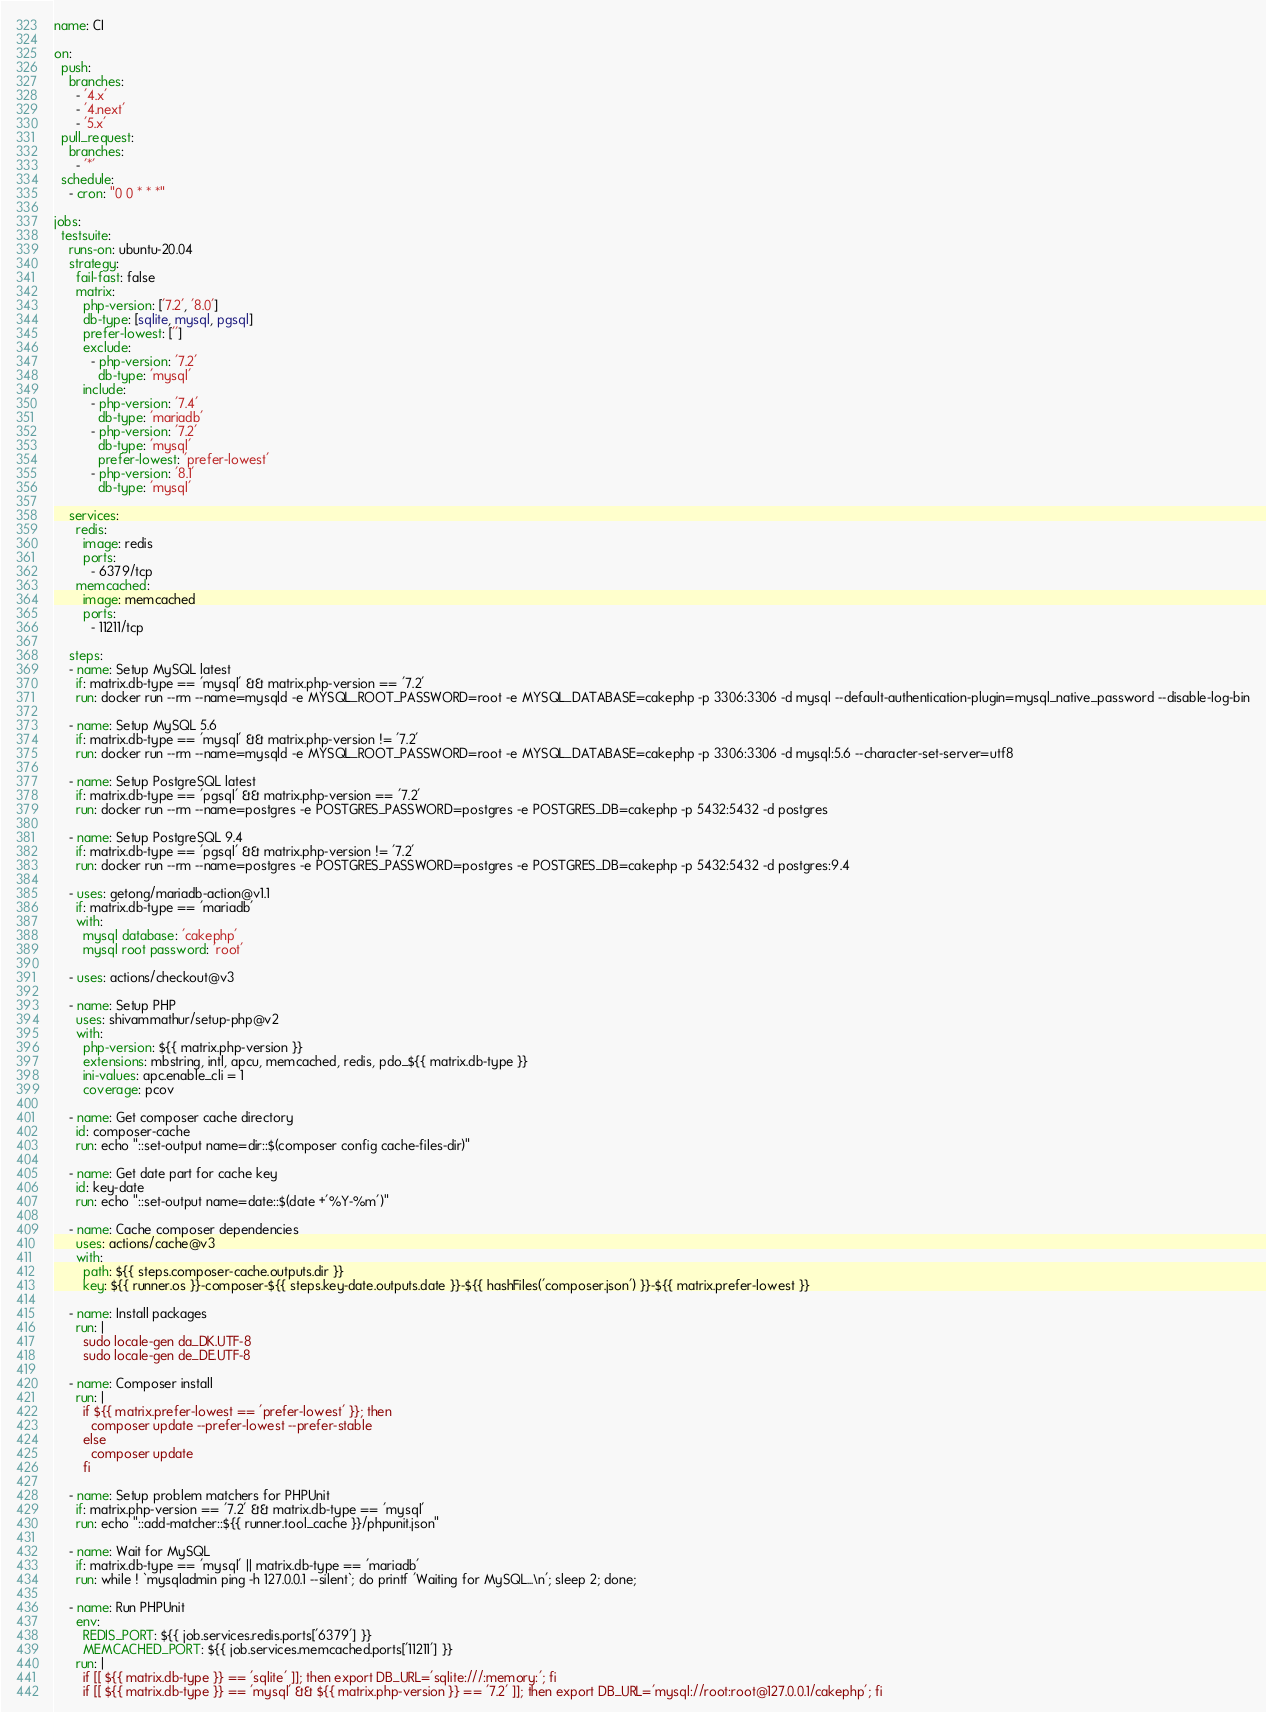Convert code to text. <code><loc_0><loc_0><loc_500><loc_500><_YAML_>name: CI

on:
  push:
    branches:
      - '4.x'
      - '4.next'
      - '5.x'
  pull_request:
    branches:
      - '*'
  schedule:
    - cron: "0 0 * * *"

jobs:
  testsuite:
    runs-on: ubuntu-20.04
    strategy:
      fail-fast: false
      matrix:
        php-version: ['7.2', '8.0']
        db-type: [sqlite, mysql, pgsql]
        prefer-lowest: ['']
        exclude:
          - php-version: '7.2'
            db-type: 'mysql'
        include:
          - php-version: '7.4'
            db-type: 'mariadb'
          - php-version: '7.2'
            db-type: 'mysql'
            prefer-lowest: 'prefer-lowest'
          - php-version: '8.1'
            db-type: 'mysql'

    services:
      redis:
        image: redis
        ports:
          - 6379/tcp
      memcached:
        image: memcached
        ports:
          - 11211/tcp

    steps:
    - name: Setup MySQL latest
      if: matrix.db-type == 'mysql' && matrix.php-version == '7.2'
      run: docker run --rm --name=mysqld -e MYSQL_ROOT_PASSWORD=root -e MYSQL_DATABASE=cakephp -p 3306:3306 -d mysql --default-authentication-plugin=mysql_native_password --disable-log-bin

    - name: Setup MySQL 5.6
      if: matrix.db-type == 'mysql' && matrix.php-version != '7.2'
      run: docker run --rm --name=mysqld -e MYSQL_ROOT_PASSWORD=root -e MYSQL_DATABASE=cakephp -p 3306:3306 -d mysql:5.6 --character-set-server=utf8

    - name: Setup PostgreSQL latest
      if: matrix.db-type == 'pgsql' && matrix.php-version == '7.2'
      run: docker run --rm --name=postgres -e POSTGRES_PASSWORD=postgres -e POSTGRES_DB=cakephp -p 5432:5432 -d postgres

    - name: Setup PostgreSQL 9.4
      if: matrix.db-type == 'pgsql' && matrix.php-version != '7.2'
      run: docker run --rm --name=postgres -e POSTGRES_PASSWORD=postgres -e POSTGRES_DB=cakephp -p 5432:5432 -d postgres:9.4

    - uses: getong/mariadb-action@v1.1
      if: matrix.db-type == 'mariadb'
      with:
        mysql database: 'cakephp'
        mysql root password: 'root'

    - uses: actions/checkout@v3

    - name: Setup PHP
      uses: shivammathur/setup-php@v2
      with:
        php-version: ${{ matrix.php-version }}
        extensions: mbstring, intl, apcu, memcached, redis, pdo_${{ matrix.db-type }}
        ini-values: apc.enable_cli = 1
        coverage: pcov

    - name: Get composer cache directory
      id: composer-cache
      run: echo "::set-output name=dir::$(composer config cache-files-dir)"

    - name: Get date part for cache key
      id: key-date
      run: echo "::set-output name=date::$(date +'%Y-%m')"

    - name: Cache composer dependencies
      uses: actions/cache@v3
      with:
        path: ${{ steps.composer-cache.outputs.dir }}
        key: ${{ runner.os }}-composer-${{ steps.key-date.outputs.date }}-${{ hashFiles('composer.json') }}-${{ matrix.prefer-lowest }}

    - name: Install packages
      run: |
        sudo locale-gen da_DK.UTF-8
        sudo locale-gen de_DE.UTF-8

    - name: Composer install
      run: |
        if ${{ matrix.prefer-lowest == 'prefer-lowest' }}; then
          composer update --prefer-lowest --prefer-stable
        else
          composer update
        fi

    - name: Setup problem matchers for PHPUnit
      if: matrix.php-version == '7.2' && matrix.db-type == 'mysql'
      run: echo "::add-matcher::${{ runner.tool_cache }}/phpunit.json"

    - name: Wait for MySQL
      if: matrix.db-type == 'mysql' || matrix.db-type == 'mariadb'
      run: while ! `mysqladmin ping -h 127.0.0.1 --silent`; do printf 'Waiting for MySQL...\n'; sleep 2; done;

    - name: Run PHPUnit
      env:
        REDIS_PORT: ${{ job.services.redis.ports['6379'] }}
        MEMCACHED_PORT: ${{ job.services.memcached.ports['11211'] }}
      run: |
        if [[ ${{ matrix.db-type }} == 'sqlite' ]]; then export DB_URL='sqlite:///:memory:'; fi
        if [[ ${{ matrix.db-type }} == 'mysql' && ${{ matrix.php-version }} == '7.2' ]]; then export DB_URL='mysql://root:root@127.0.0.1/cakephp'; fi</code> 